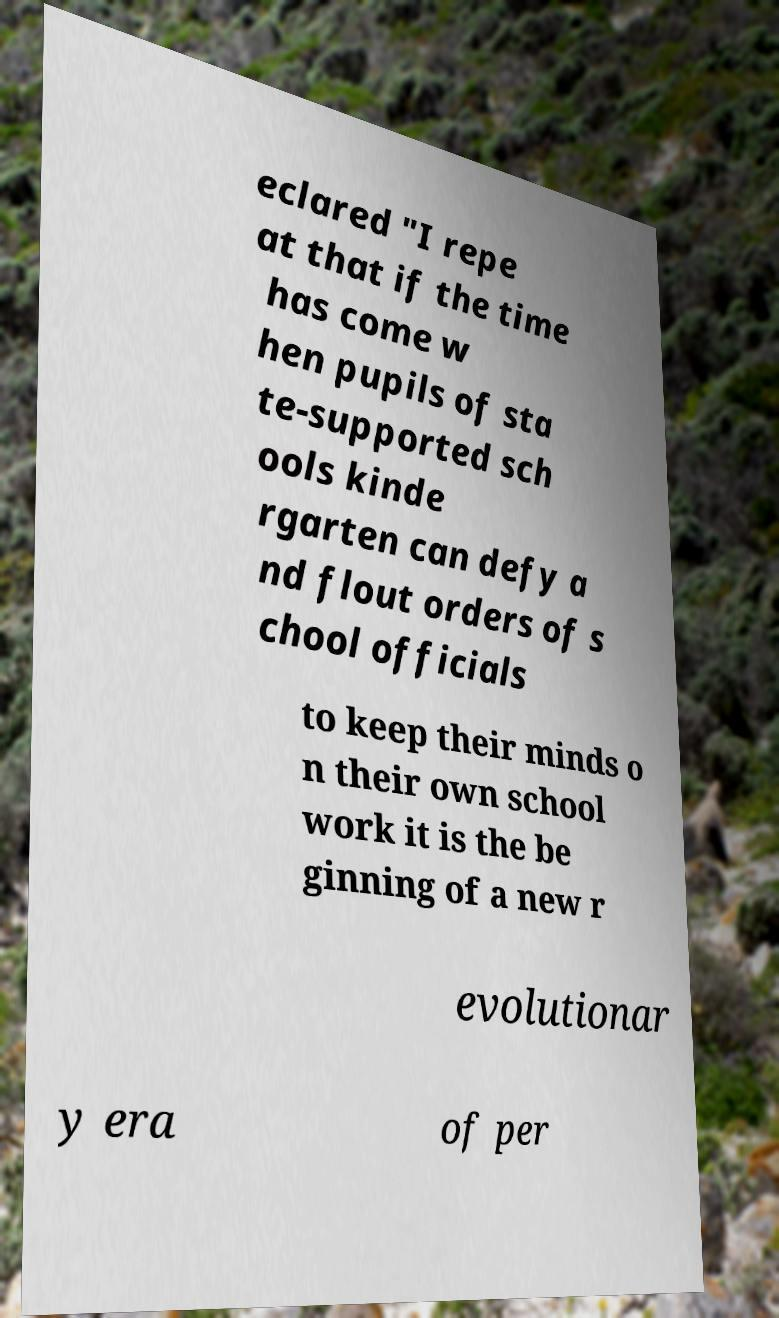Please identify and transcribe the text found in this image. eclared "I repe at that if the time has come w hen pupils of sta te-supported sch ools kinde rgarten can defy a nd flout orders of s chool officials to keep their minds o n their own school work it is the be ginning of a new r evolutionar y era of per 